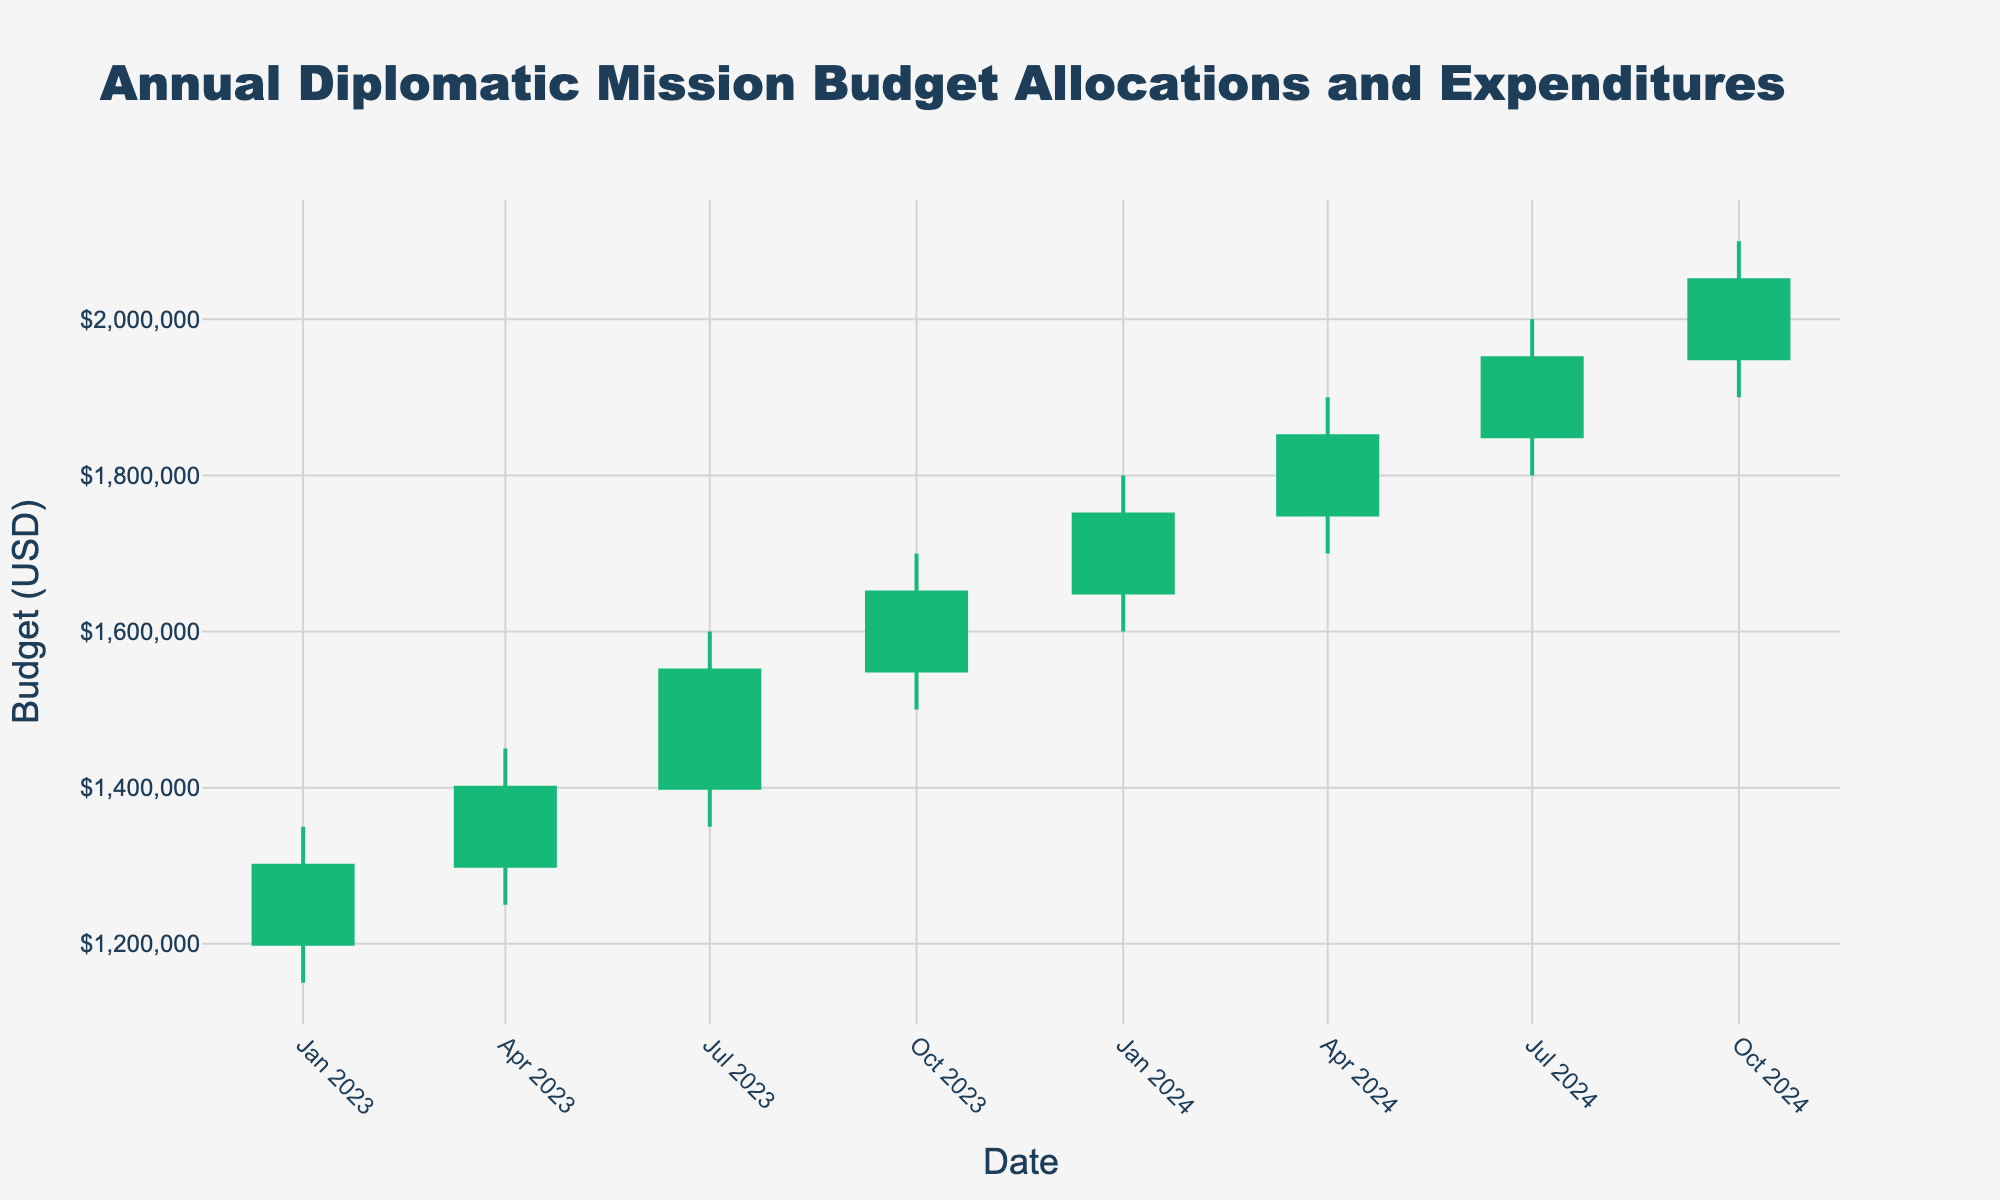When is the highest budget allocation in the chart? The highest budget allocation is represented by the highest 'High' value in the OHLC chart, which occurs in October 2024.
Answer: October 2024 What is the range of budget allocations and expenditures for the year 2023? The range is calculated by subtracting the lowest 'Low' value from the highest 'High' value for the year 2023. The highest value is $1,700,000 in October 2023, and the lowest value is $1,150,000 in January 2023. So, the range is $1,700,000 - $1,150,000.
Answer: $550,000 Which quarter shows the greatest increase in the closing budget from the previous quarter? To determine the greatest quarterly increase, we need to look at the difference in the 'Close' value between consecutive quarters. The largest increase happens between July 2023 ($1,550,000) and October 2023 ($1,650,000), which is $100,000.
Answer: Q3 to Q4 2023 By how much does the closing budget in January 2024 exceed that in January 2023? The January 2024 'Close' value is $1,750,000 and the January 2023 'Close' value is $1,300,000. The difference is $1,750,000 - $1,300,000.
Answer: $450,000 Which quarter of 2024 dominates with the highest opening budget? Compare the 'Open' values for all quarters of 2024. The highest 'Open' value is $1,950,000 in October 2024.
Answer: Q4 2024 Is there any quarter where the budget allocation did not increase compared to the previous quarter? By reviewing the opening and closing values, we see that every quarter shows an increase from the previous quarter, indicating a continuous budget increase.
Answer: No What is the trend observed in the closing budget from Q1 2023 to Q4 2024? The 'Close' values in the chart show an increasing trend from $1,300,000 in January 2023 to $2,050,000 in October 2024.
Answer: Increasing How much higher is the budget in October 2024 compared to October 2023? The 'Close' values in October 2024 and October 2023 are $2,050,000 and $1,650,000 respectively. The difference is $2,050,000 - $1,650,000.
Answer: $400,000 Which quarter had the lowest high budget in 2024? Compare the 'High' values for all quarters of 2024. The lowest 'High' budget is $1,800,000 in Q1 2024.
Answer: Q1 2024 What is the trend in the high budget values throughout 2023 and 2024? The 'High' values increase each quarter, from $1,350,000 in January 2023 to $2,100,000 in October 2024, indicating a rising trend.
Answer: Increasing 